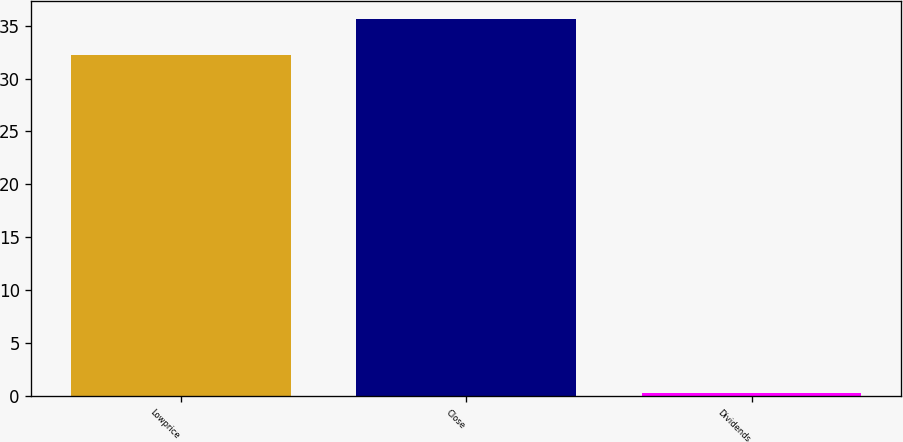Convert chart. <chart><loc_0><loc_0><loc_500><loc_500><bar_chart><fcel>Lowprice<fcel>Close<fcel>Dividends<nl><fcel>32.18<fcel>35.59<fcel>0.28<nl></chart> 